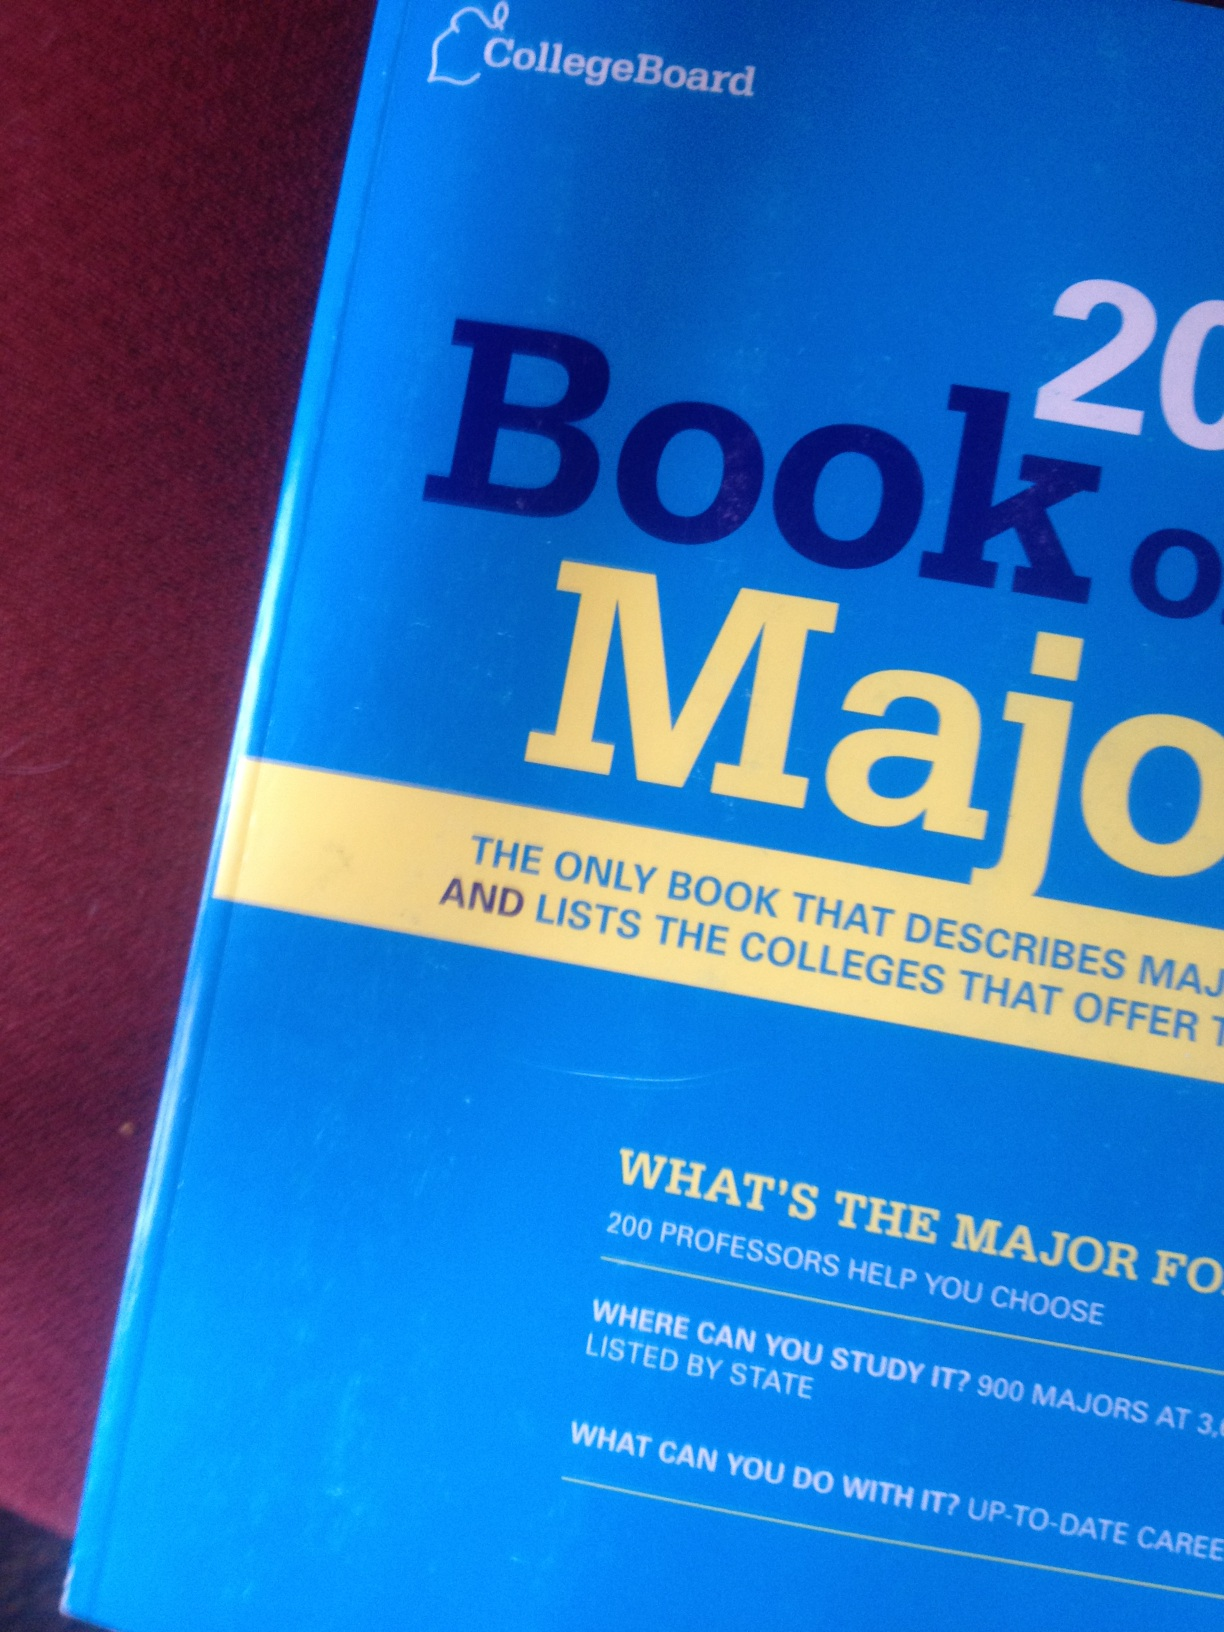What kind of information does this book provide about career prospects? The 'Book of Majors 2014' offers up-to-date information regarding career prospects for various academic fields. It discusses what you can do with each major, potential job roles, and the career paths commonly associated with those majors. Additionally, the book provides data on job market trends, salary expectations, and the skills needed to succeed in those careers. Which majors are in high demand according to this book? The book highlights majors that are in high demand based on current job market trends. For example, fields such as computer science, healthcare, engineering, and data science are often emphasized due to their increasing relevance and job growth. In the healthcare sector, majors like nursing and biomedical engineering are particularly noted for their high demand. Meanwhile, technology-driven majors, such as cybersecurity, artificial intelligence, and software development, reflect the ongoing technological advancements and the need for skilled professionals in these areas. Are there any creative fields covered in this book? Yes, the book also covers a variety of creative fields. It discusses majors such as fine arts, graphic design, creative writing, theater, and film production. These sections provide insights into the skills required, potential career opportunities, and the artistic and professional development pathways available in these fields. For instance, in graphic design, the book would delve into topics such as visual communication, digital illustration, and the impact of design on consumer engagement. Imagine if the book had a special section on futuristic careers. What careers might it feature? If the 'Book of Majors 2014' had a special section on futuristic careers, it might feature intriguing fields such as space tourism, holographic entertainment design, AI ethics consulting, virtual reality architecture, and sustainable energy engineering. These majors would prepare students for roles in developing advanced space travel experiences, creating immersive holographic events, navigating the ethical implications of AI technologies, designing virtual environments for various applications, and innovating solutions for renewable energy challenges. 